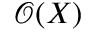Convert formula to latex. <formula><loc_0><loc_0><loc_500><loc_500>{ \mathcal { O } } ( X )</formula> 